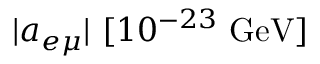Convert formula to latex. <formula><loc_0><loc_0><loc_500><loc_500>| a _ { e \mu } | [ 1 0 ^ { - 2 3 } { G e V } ]</formula> 